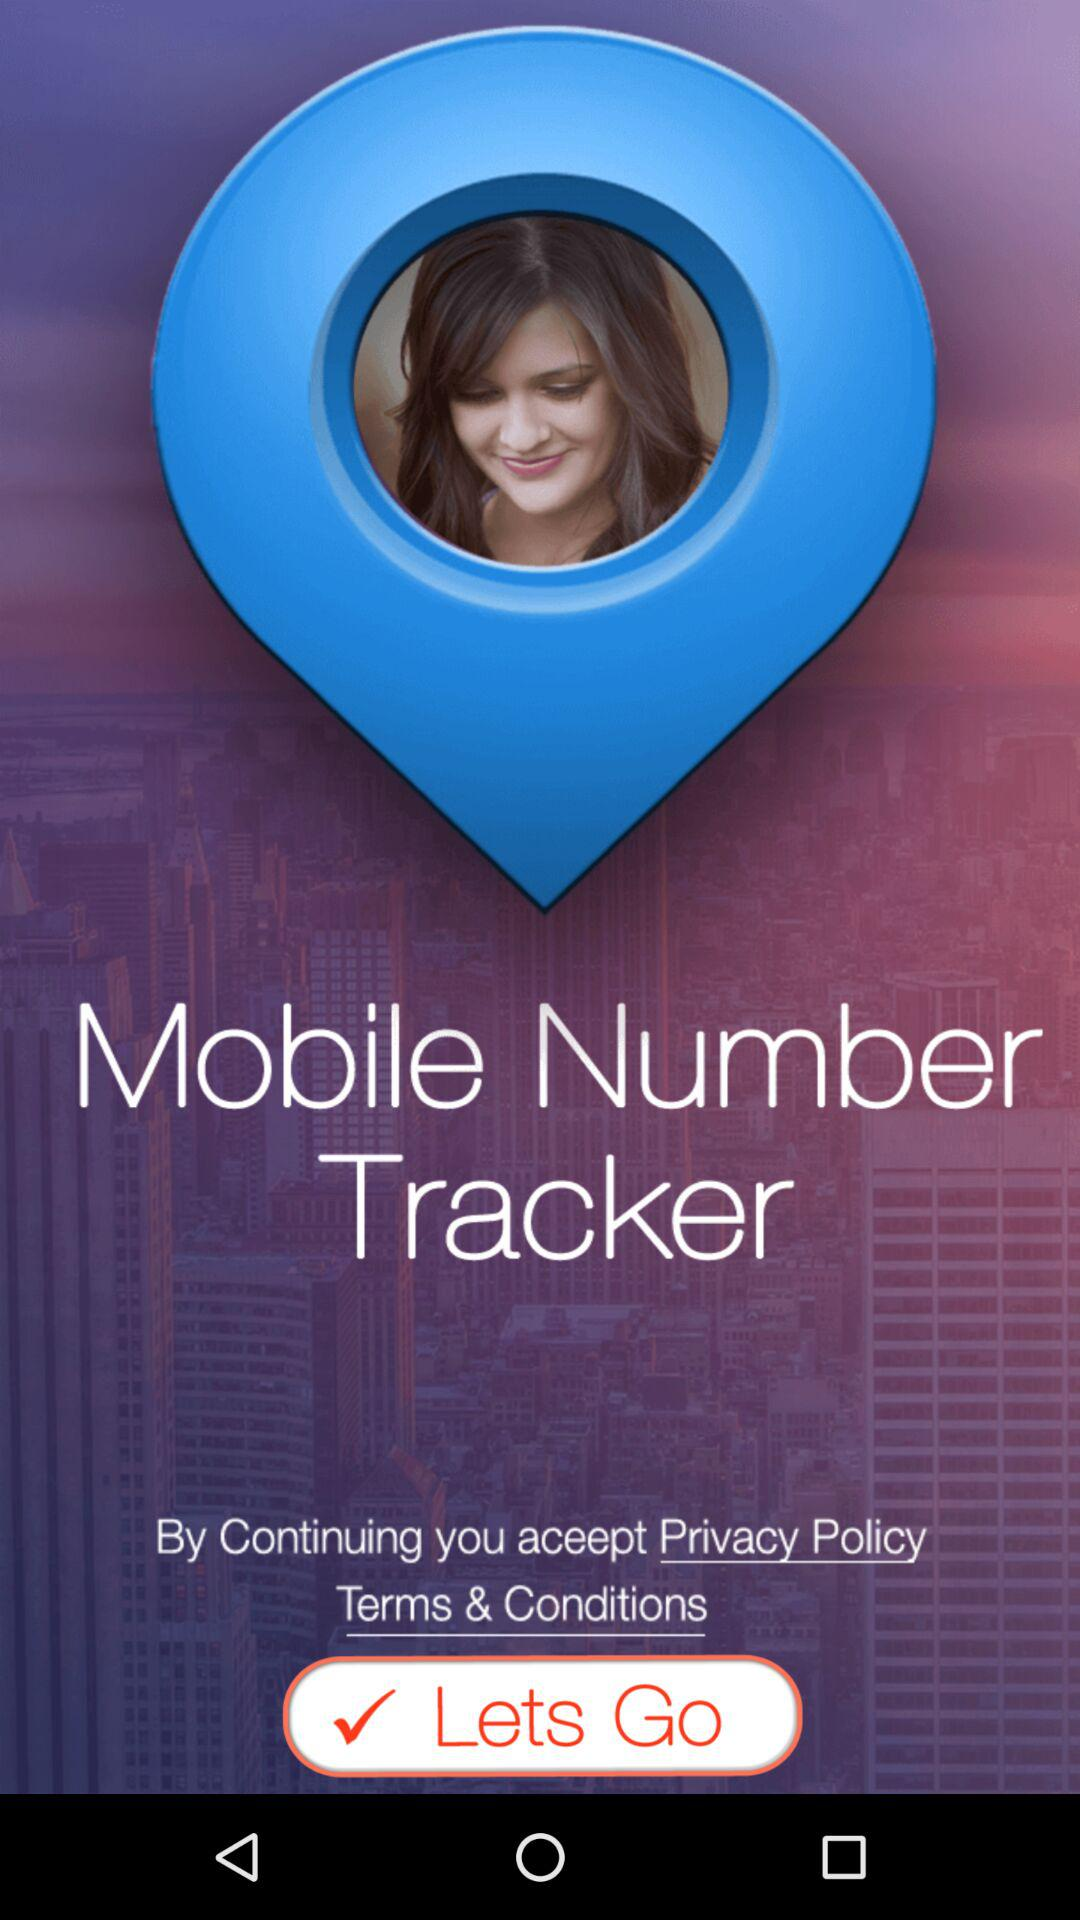Who is continuing?
When the provided information is insufficient, respond with <no answer>. <no answer> 